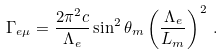<formula> <loc_0><loc_0><loc_500><loc_500>\Gamma _ { e \mu } = \frac { 2 \pi ^ { 2 } c } { \Lambda _ { e } } \sin ^ { 2 } \theta _ { m } \left ( \frac { \Lambda _ { e } } { L _ { m } } \right ) ^ { 2 } \, .</formula> 